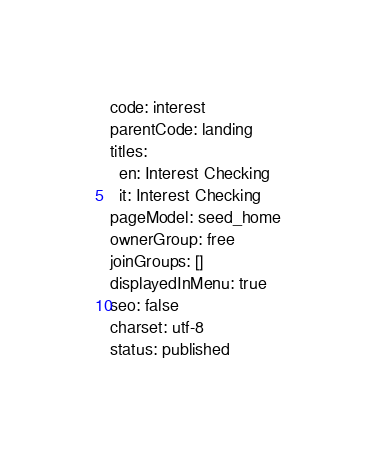Convert code to text. <code><loc_0><loc_0><loc_500><loc_500><_YAML_>code: interest
parentCode: landing
titles:
  en: Interest Checking
  it: Interest Checking
pageModel: seed_home
ownerGroup: free
joinGroups: []
displayedInMenu: true
seo: false
charset: utf-8
status: published
</code> 